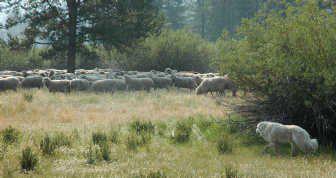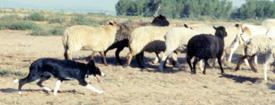The first image is the image on the left, the second image is the image on the right. Examine the images to the left and right. Is the description "A dog is herding sheep." accurate? Answer yes or no. Yes. The first image is the image on the left, the second image is the image on the right. Considering the images on both sides, is "In the right image, there's a single dog herding some sheep on its own." valid? Answer yes or no. Yes. 